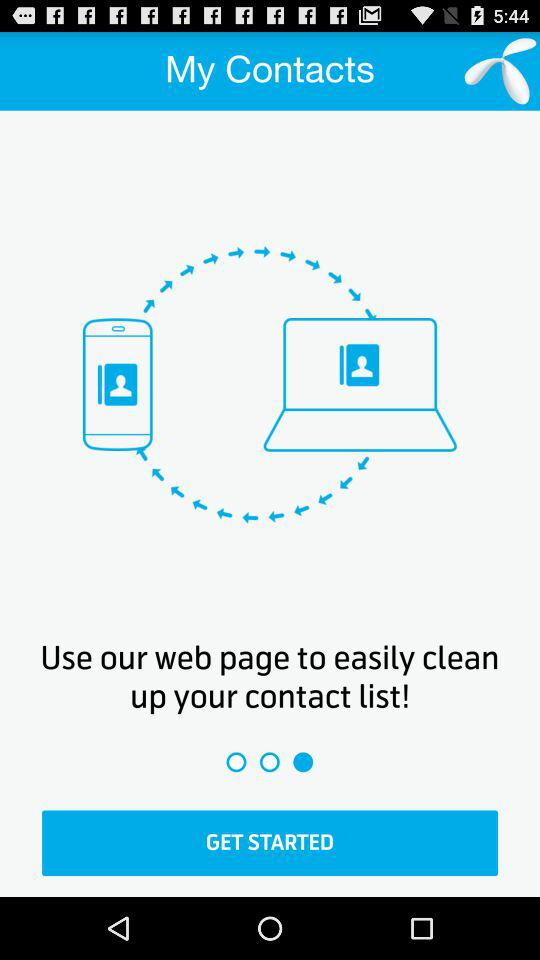What is the application name? The application name is "My Contacts". 